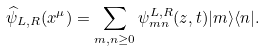Convert formula to latex. <formula><loc_0><loc_0><loc_500><loc_500>\widehat { \psi } _ { L , R } ( x ^ { \mu } ) = \sum _ { m , n \geq 0 } \psi _ { m n } ^ { L , R } ( z , t ) | m \rangle \langle n | .</formula> 